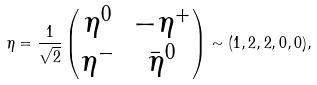Convert formula to latex. <formula><loc_0><loc_0><loc_500><loc_500>\eta = \frac { 1 } { \sqrt { 2 } } \begin{pmatrix} \eta ^ { 0 } & - \eta ^ { + } \\ \eta ^ { - } & \bar { \eta } ^ { 0 } \end{pmatrix} \sim ( 1 , 2 , 2 , 0 , 0 ) ,</formula> 